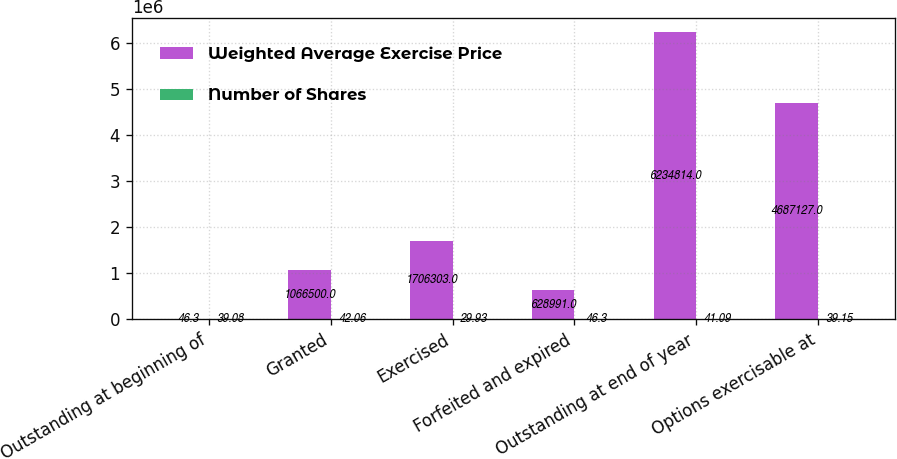Convert chart to OTSL. <chart><loc_0><loc_0><loc_500><loc_500><stacked_bar_chart><ecel><fcel>Outstanding at beginning of<fcel>Granted<fcel>Exercised<fcel>Forfeited and expired<fcel>Outstanding at end of year<fcel>Options exercisable at<nl><fcel>Weighted Average Exercise Price<fcel>46.3<fcel>1.0665e+06<fcel>1.7063e+06<fcel>628991<fcel>6.23481e+06<fcel>4.68713e+06<nl><fcel>Number of Shares<fcel>39.08<fcel>42.06<fcel>29.93<fcel>46.3<fcel>41.09<fcel>39.15<nl></chart> 